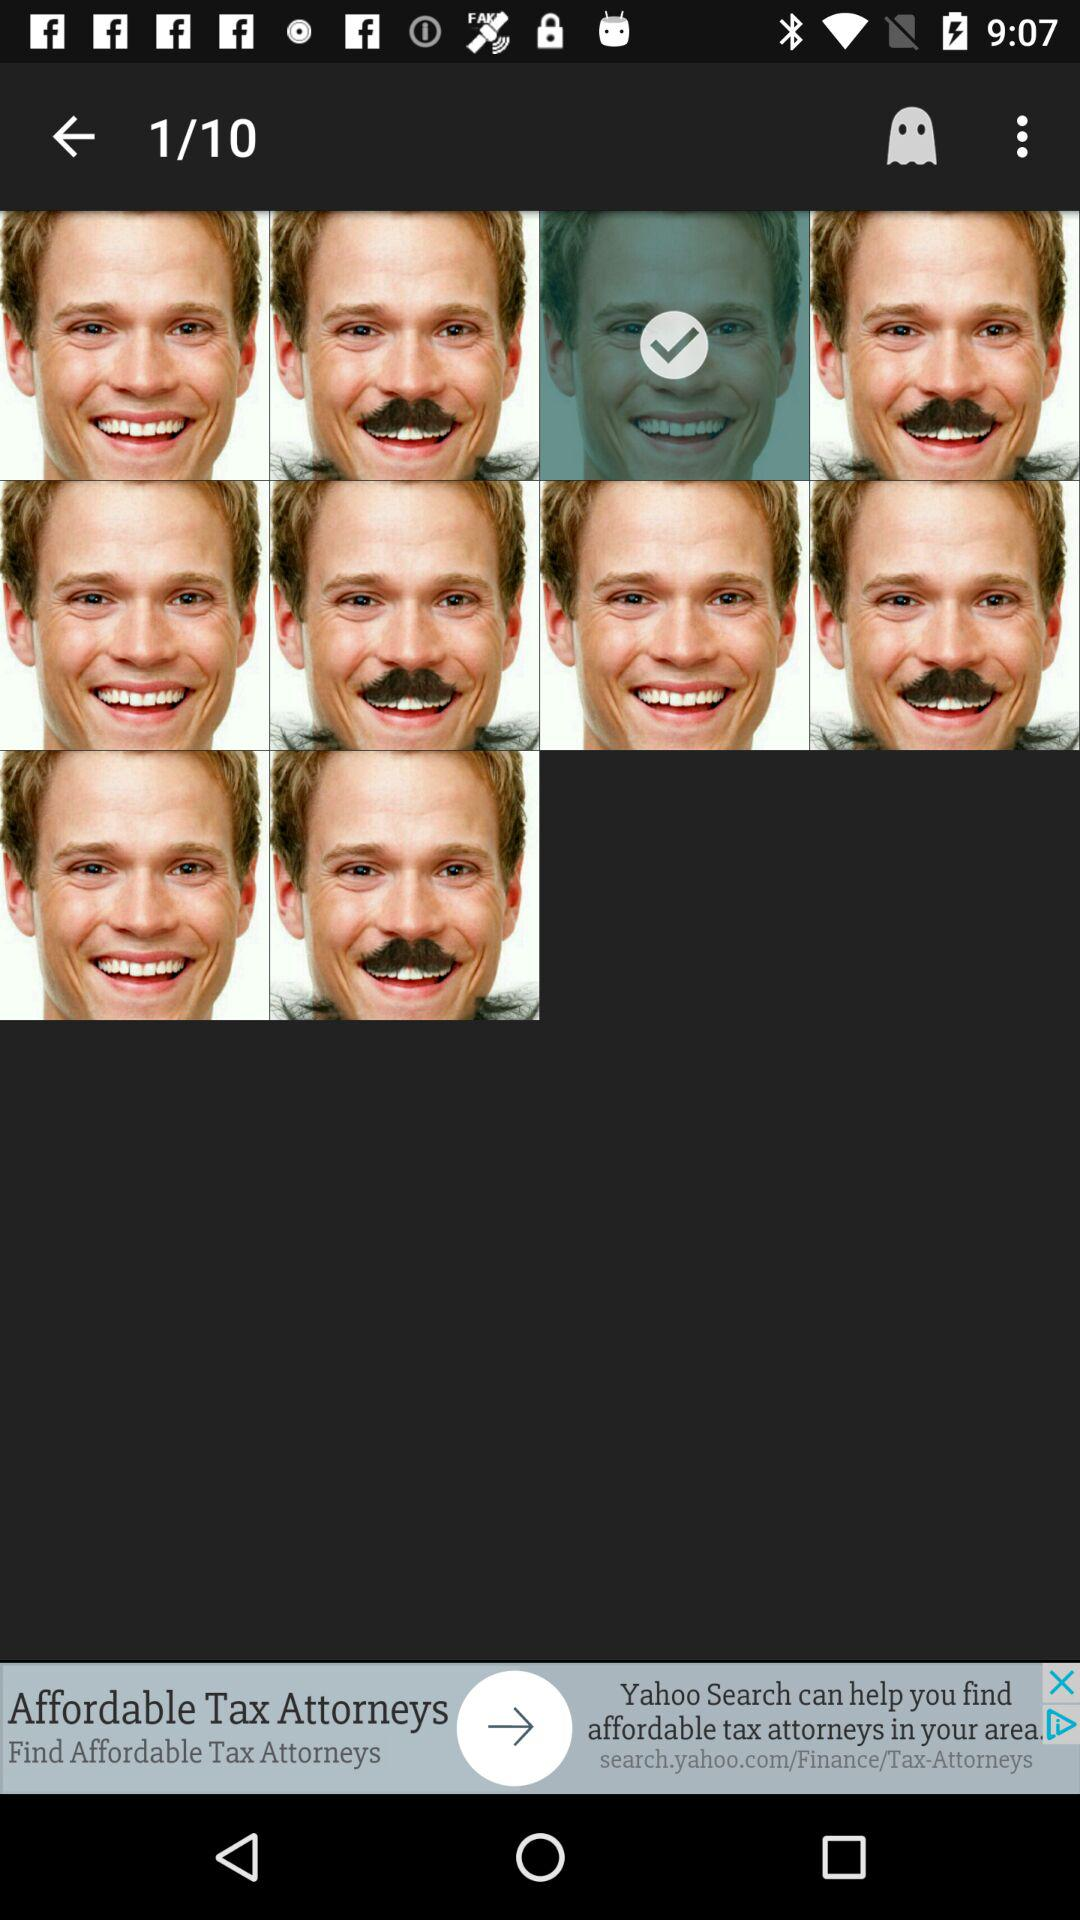How many images are selected? There is 1 image selected. 